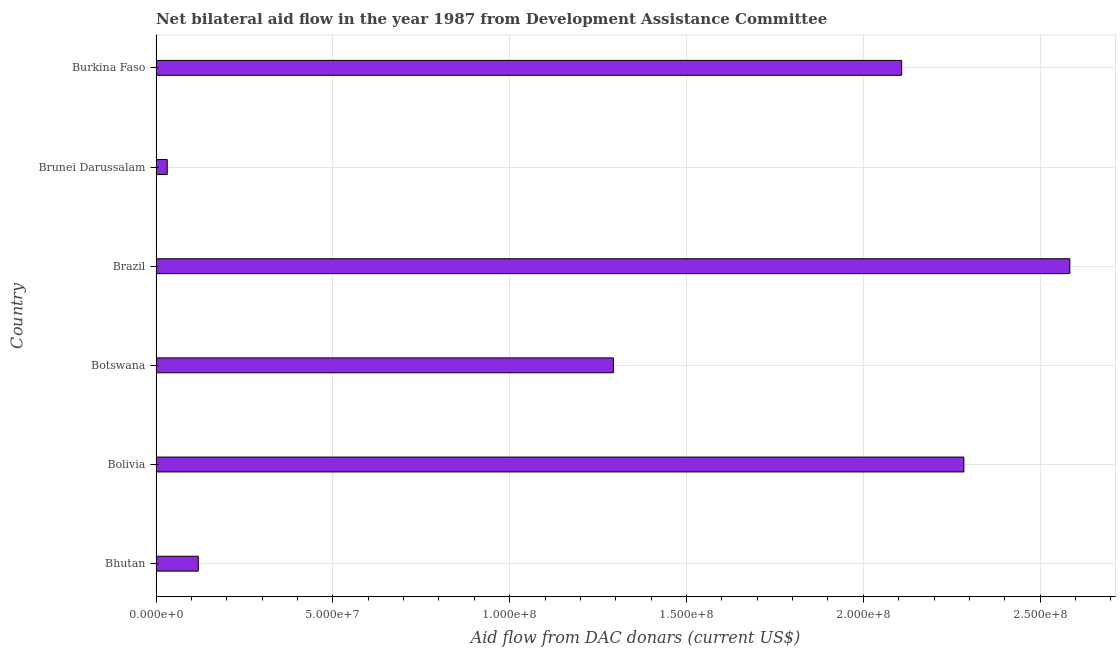Does the graph contain any zero values?
Offer a very short reply. No. Does the graph contain grids?
Provide a short and direct response. Yes. What is the title of the graph?
Make the answer very short. Net bilateral aid flow in the year 1987 from Development Assistance Committee. What is the label or title of the X-axis?
Offer a terse response. Aid flow from DAC donars (current US$). What is the net bilateral aid flows from dac donors in Burkina Faso?
Your answer should be compact. 2.11e+08. Across all countries, what is the maximum net bilateral aid flows from dac donors?
Make the answer very short. 2.58e+08. Across all countries, what is the minimum net bilateral aid flows from dac donors?
Make the answer very short. 3.17e+06. In which country was the net bilateral aid flows from dac donors maximum?
Your answer should be very brief. Brazil. In which country was the net bilateral aid flows from dac donors minimum?
Ensure brevity in your answer.  Brunei Darussalam. What is the sum of the net bilateral aid flows from dac donors?
Your answer should be compact. 8.42e+08. What is the difference between the net bilateral aid flows from dac donors in Bolivia and Botswana?
Your response must be concise. 9.91e+07. What is the average net bilateral aid flows from dac donors per country?
Make the answer very short. 1.40e+08. What is the median net bilateral aid flows from dac donors?
Offer a very short reply. 1.70e+08. In how many countries, is the net bilateral aid flows from dac donors greater than 210000000 US$?
Offer a very short reply. 3. What is the ratio of the net bilateral aid flows from dac donors in Bhutan to that in Brazil?
Keep it short and to the point. 0.05. Is the net bilateral aid flows from dac donors in Bhutan less than that in Botswana?
Give a very brief answer. Yes. Is the difference between the net bilateral aid flows from dac donors in Bhutan and Brunei Darussalam greater than the difference between any two countries?
Make the answer very short. No. What is the difference between the highest and the second highest net bilateral aid flows from dac donors?
Offer a very short reply. 3.00e+07. Is the sum of the net bilateral aid flows from dac donors in Bolivia and Brazil greater than the maximum net bilateral aid flows from dac donors across all countries?
Give a very brief answer. Yes. What is the difference between the highest and the lowest net bilateral aid flows from dac donors?
Your answer should be very brief. 2.55e+08. In how many countries, is the net bilateral aid flows from dac donors greater than the average net bilateral aid flows from dac donors taken over all countries?
Offer a very short reply. 3. How many bars are there?
Your answer should be very brief. 6. Are all the bars in the graph horizontal?
Your response must be concise. Yes. What is the difference between two consecutive major ticks on the X-axis?
Provide a short and direct response. 5.00e+07. What is the Aid flow from DAC donars (current US$) in Bhutan?
Provide a succinct answer. 1.20e+07. What is the Aid flow from DAC donars (current US$) of Bolivia?
Offer a very short reply. 2.28e+08. What is the Aid flow from DAC donars (current US$) of Botswana?
Provide a short and direct response. 1.29e+08. What is the Aid flow from DAC donars (current US$) in Brazil?
Offer a very short reply. 2.58e+08. What is the Aid flow from DAC donars (current US$) of Brunei Darussalam?
Give a very brief answer. 3.17e+06. What is the Aid flow from DAC donars (current US$) in Burkina Faso?
Offer a terse response. 2.11e+08. What is the difference between the Aid flow from DAC donars (current US$) in Bhutan and Bolivia?
Your answer should be compact. -2.16e+08. What is the difference between the Aid flow from DAC donars (current US$) in Bhutan and Botswana?
Ensure brevity in your answer.  -1.17e+08. What is the difference between the Aid flow from DAC donars (current US$) in Bhutan and Brazil?
Make the answer very short. -2.46e+08. What is the difference between the Aid flow from DAC donars (current US$) in Bhutan and Brunei Darussalam?
Provide a succinct answer. 8.79e+06. What is the difference between the Aid flow from DAC donars (current US$) in Bhutan and Burkina Faso?
Your answer should be very brief. -1.99e+08. What is the difference between the Aid flow from DAC donars (current US$) in Bolivia and Botswana?
Make the answer very short. 9.91e+07. What is the difference between the Aid flow from DAC donars (current US$) in Bolivia and Brazil?
Your answer should be compact. -3.00e+07. What is the difference between the Aid flow from DAC donars (current US$) in Bolivia and Brunei Darussalam?
Make the answer very short. 2.25e+08. What is the difference between the Aid flow from DAC donars (current US$) in Bolivia and Burkina Faso?
Offer a very short reply. 1.76e+07. What is the difference between the Aid flow from DAC donars (current US$) in Botswana and Brazil?
Your answer should be compact. -1.29e+08. What is the difference between the Aid flow from DAC donars (current US$) in Botswana and Brunei Darussalam?
Give a very brief answer. 1.26e+08. What is the difference between the Aid flow from DAC donars (current US$) in Botswana and Burkina Faso?
Your answer should be very brief. -8.15e+07. What is the difference between the Aid flow from DAC donars (current US$) in Brazil and Brunei Darussalam?
Make the answer very short. 2.55e+08. What is the difference between the Aid flow from DAC donars (current US$) in Brazil and Burkina Faso?
Give a very brief answer. 4.76e+07. What is the difference between the Aid flow from DAC donars (current US$) in Brunei Darussalam and Burkina Faso?
Make the answer very short. -2.08e+08. What is the ratio of the Aid flow from DAC donars (current US$) in Bhutan to that in Bolivia?
Your answer should be very brief. 0.05. What is the ratio of the Aid flow from DAC donars (current US$) in Bhutan to that in Botswana?
Your answer should be compact. 0.09. What is the ratio of the Aid flow from DAC donars (current US$) in Bhutan to that in Brazil?
Offer a terse response. 0.05. What is the ratio of the Aid flow from DAC donars (current US$) in Bhutan to that in Brunei Darussalam?
Provide a succinct answer. 3.77. What is the ratio of the Aid flow from DAC donars (current US$) in Bhutan to that in Burkina Faso?
Ensure brevity in your answer.  0.06. What is the ratio of the Aid flow from DAC donars (current US$) in Bolivia to that in Botswana?
Keep it short and to the point. 1.77. What is the ratio of the Aid flow from DAC donars (current US$) in Bolivia to that in Brazil?
Make the answer very short. 0.88. What is the ratio of the Aid flow from DAC donars (current US$) in Bolivia to that in Brunei Darussalam?
Provide a short and direct response. 72.07. What is the ratio of the Aid flow from DAC donars (current US$) in Bolivia to that in Burkina Faso?
Give a very brief answer. 1.08. What is the ratio of the Aid flow from DAC donars (current US$) in Botswana to that in Brazil?
Provide a short and direct response. 0.5. What is the ratio of the Aid flow from DAC donars (current US$) in Botswana to that in Brunei Darussalam?
Provide a succinct answer. 40.8. What is the ratio of the Aid flow from DAC donars (current US$) in Botswana to that in Burkina Faso?
Make the answer very short. 0.61. What is the ratio of the Aid flow from DAC donars (current US$) in Brazil to that in Brunei Darussalam?
Provide a succinct answer. 81.51. What is the ratio of the Aid flow from DAC donars (current US$) in Brazil to that in Burkina Faso?
Make the answer very short. 1.23. What is the ratio of the Aid flow from DAC donars (current US$) in Brunei Darussalam to that in Burkina Faso?
Provide a succinct answer. 0.01. 